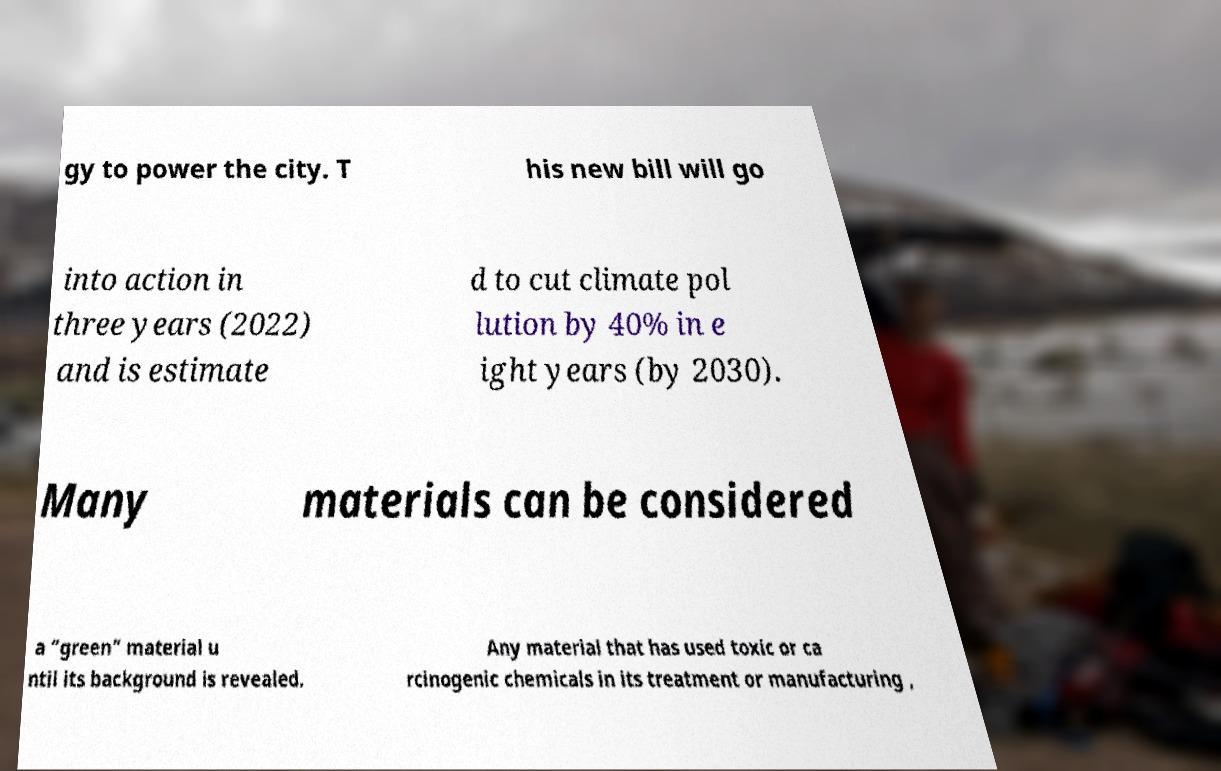Please identify and transcribe the text found in this image. gy to power the city. T his new bill will go into action in three years (2022) and is estimate d to cut climate pol lution by 40% in e ight years (by 2030). Many materials can be considered a “green” material u ntil its background is revealed. Any material that has used toxic or ca rcinogenic chemicals in its treatment or manufacturing , 